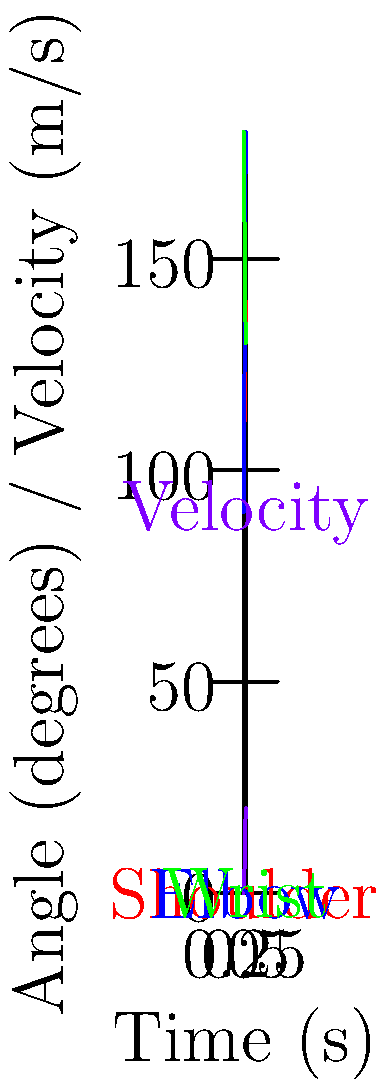In the context of throwing biomechanics, analyze the graph showing joint angles and velocity over time. Which principle of throwing mechanics is most clearly illustrated by the sequential timing of peak angles for the shoulder, elbow, and wrist joints? To answer this question, let's analyze the graph step-by-step:

1. Observe the curves:
   - Red curve ("+") represents the shoulder angle
   - Blue curve ("*") represents the elbow angle
   - Green curve ("x") represents the wrist angle
   - Purple curve ("o") represents the velocity

2. Notice the timing of peak angles:
   - Shoulder angle peaks first (around 0.5s)
   - Elbow angle peaks second (slightly after 0.5s)
   - Wrist angle starts high and decreases, reaching its minimum last

3. This sequential timing of peak angles from proximal (shoulder) to distal (wrist) joints illustrates the principle of proximal-to-distal sequencing.

4. Proximal-to-distal sequencing is a fundamental principle in throwing biomechanics where:
   - Movement is initiated in the larger, more proximal segments (like the shoulder)
   - Energy is transferred through the kinetic chain to smaller, more distal segments (like the elbow and wrist)
   - This sequence allows for the accumulation and transfer of angular momentum, resulting in higher end-effector (hand) velocity

5. The velocity curve (purple) supports this principle:
   - It shows a rapid increase as the sequential joint rotations occur
   - Peak velocity is achieved near the end of the movement, coinciding with the wrist's minimum angle

This proximal-to-distal sequencing allows for efficient energy transfer and maximization of throwing velocity, which is crucial in propulsion-related physics.
Answer: Proximal-to-distal sequencing 